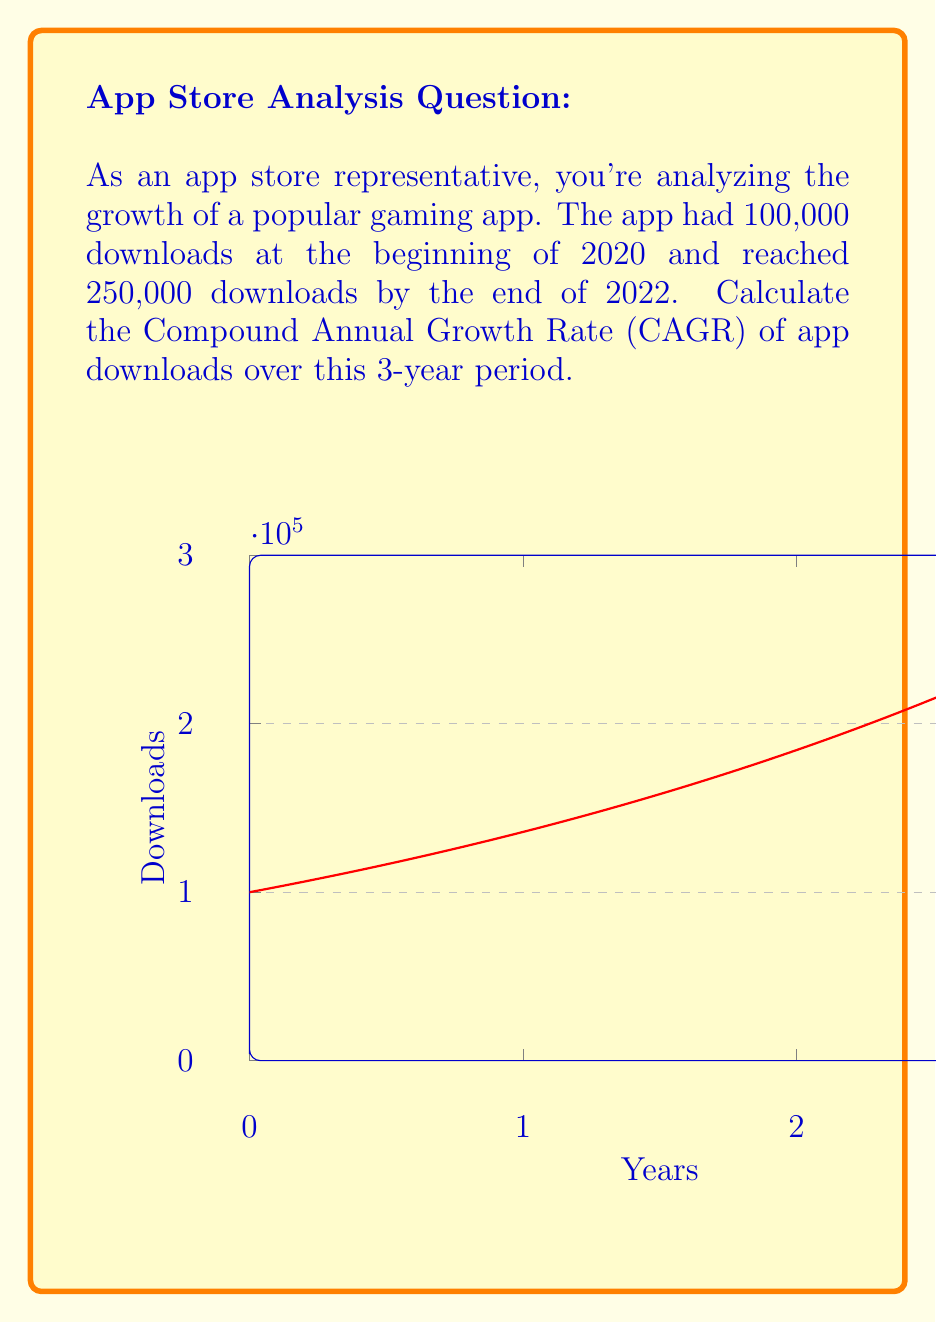Can you answer this question? To calculate the Compound Annual Growth Rate (CAGR), we'll use the formula:

$$ CAGR = \left(\frac{Ending Value}{Beginning Value}\right)^{\frac{1}{n}} - 1 $$

Where:
- Ending Value = 250,000 downloads
- Beginning Value = 100,000 downloads
- n = 3 years

Let's substitute these values into the formula:

$$ CAGR = \left(\frac{250,000}{100,000}\right)^{\frac{1}{3}} - 1 $$

$$ CAGR = (2.5)^{\frac{1}{3}} - 1 $$

$$ CAGR = 1.357771 - 1 $$

$$ CAGR = 0.357771 $$

Converting to a percentage:

$$ CAGR = 0.357771 \times 100\% = 35.7771\% $$

Rounding to two decimal places:

$$ CAGR \approx 35.78\% $$

This means the app's downloads grew at an average rate of 35.78% per year over the 3-year period.
Answer: 35.78% 